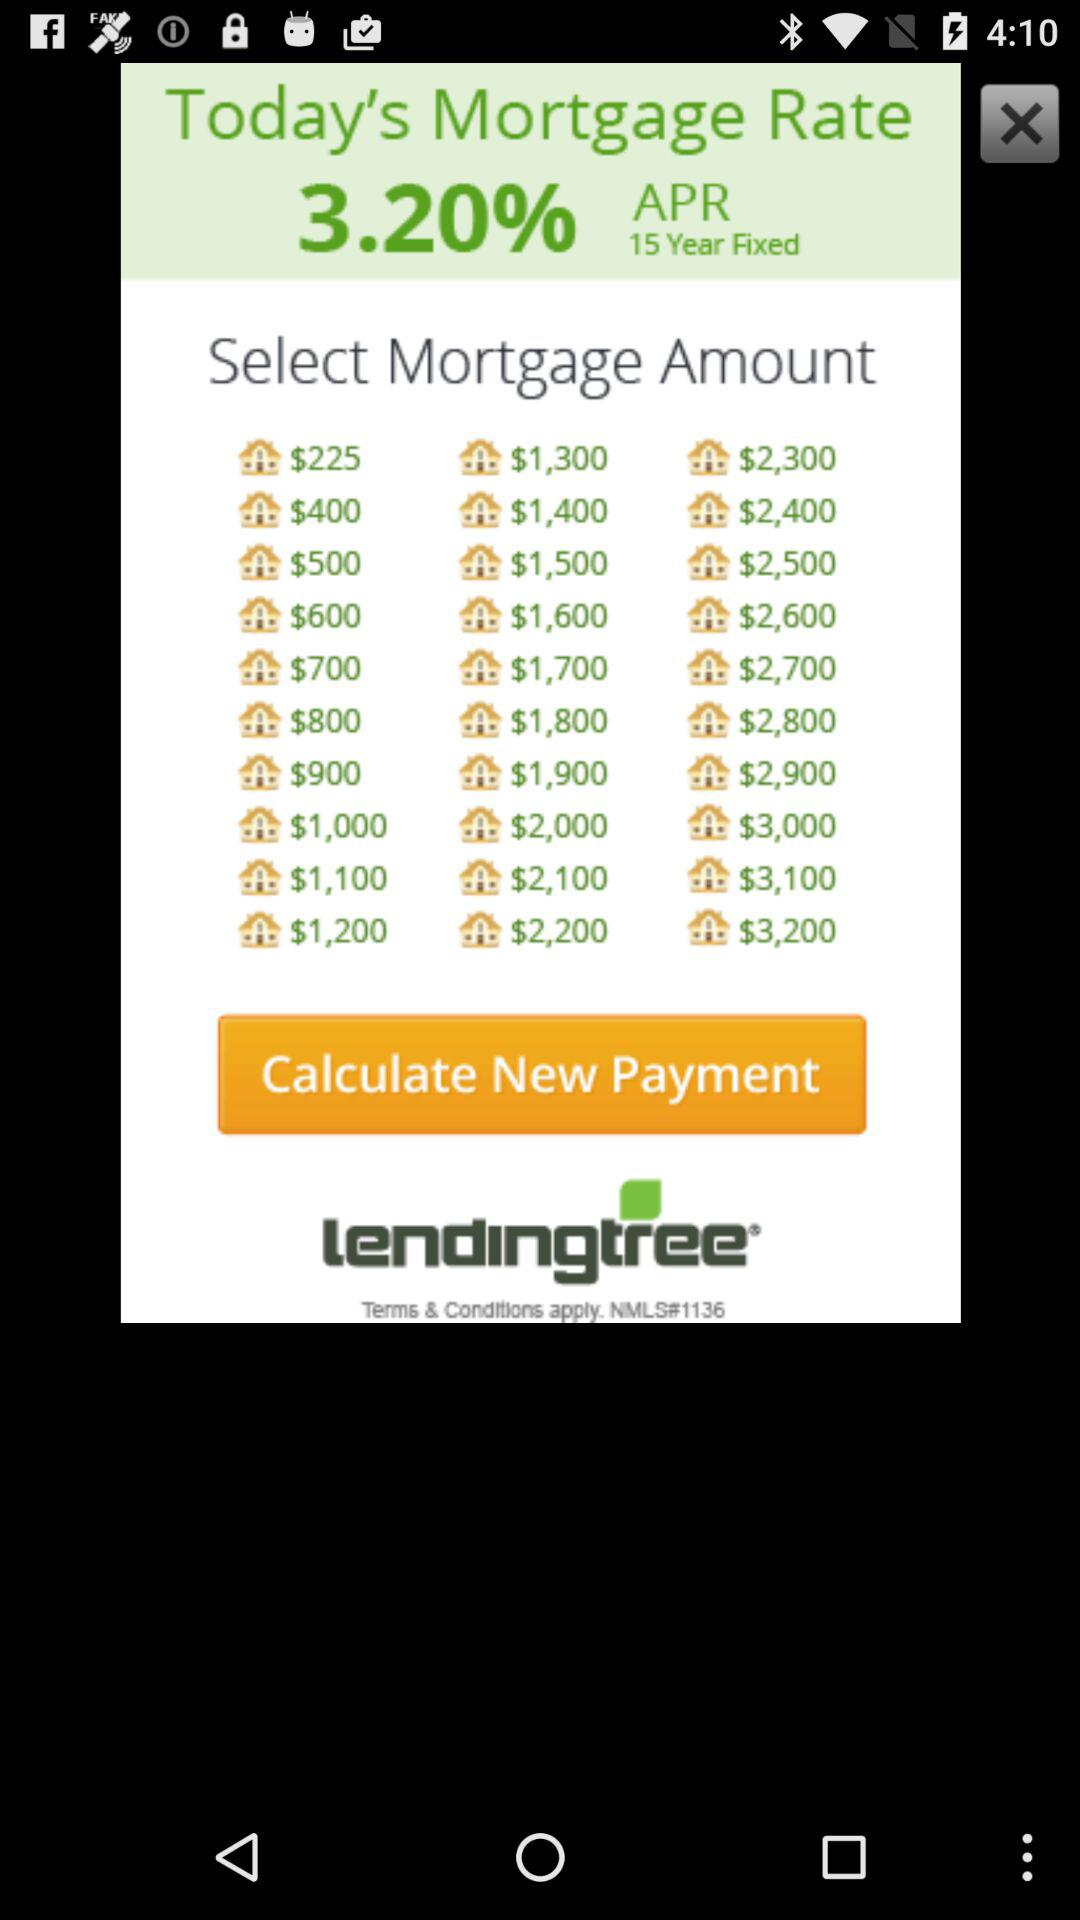What is the highest mortgage amount available?
Answer the question using a single word or phrase. $3,200 